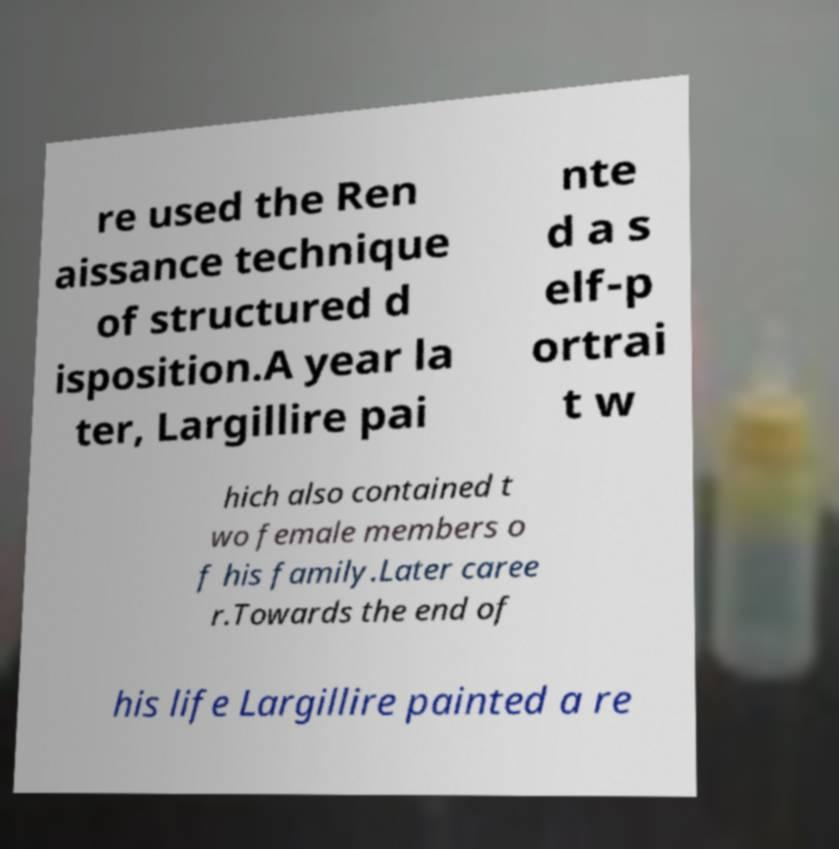For documentation purposes, I need the text within this image transcribed. Could you provide that? re used the Ren aissance technique of structured d isposition.A year la ter, Largillire pai nte d a s elf-p ortrai t w hich also contained t wo female members o f his family.Later caree r.Towards the end of his life Largillire painted a re 